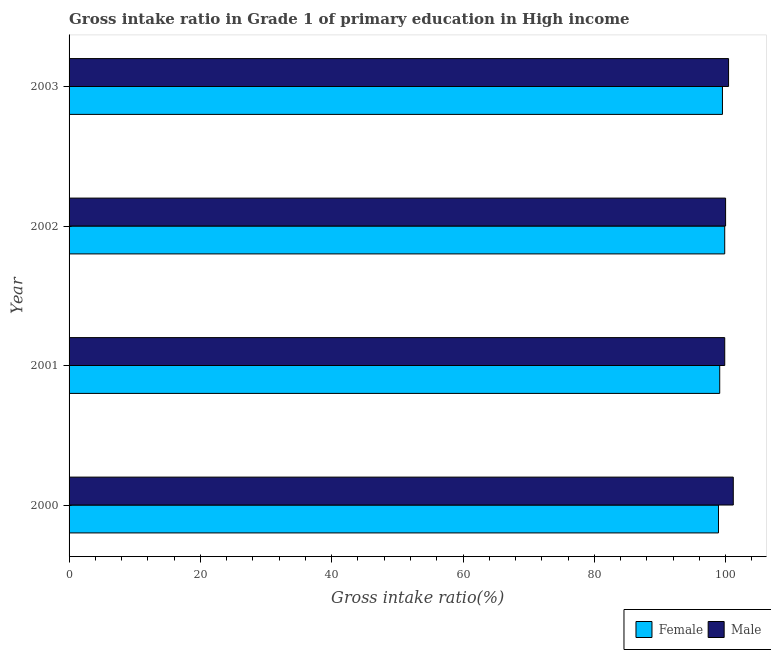How many groups of bars are there?
Keep it short and to the point. 4. Are the number of bars per tick equal to the number of legend labels?
Offer a very short reply. Yes. Are the number of bars on each tick of the Y-axis equal?
Ensure brevity in your answer.  Yes. How many bars are there on the 3rd tick from the top?
Give a very brief answer. 2. What is the gross intake ratio(male) in 2001?
Offer a terse response. 99.86. Across all years, what is the maximum gross intake ratio(female)?
Make the answer very short. 99.86. Across all years, what is the minimum gross intake ratio(female)?
Keep it short and to the point. 98.91. In which year was the gross intake ratio(female) minimum?
Offer a very short reply. 2000. What is the total gross intake ratio(male) in the graph?
Your response must be concise. 401.46. What is the difference between the gross intake ratio(male) in 2001 and that in 2002?
Your answer should be very brief. -0.13. What is the difference between the gross intake ratio(male) in 2000 and the gross intake ratio(female) in 2003?
Your response must be concise. 1.65. What is the average gross intake ratio(female) per year?
Make the answer very short. 99.35. In the year 2001, what is the difference between the gross intake ratio(male) and gross intake ratio(female)?
Your answer should be very brief. 0.76. What is the ratio of the gross intake ratio(male) in 2001 to that in 2003?
Provide a short and direct response. 0.99. Is the difference between the gross intake ratio(male) in 2000 and 2001 greater than the difference between the gross intake ratio(female) in 2000 and 2001?
Keep it short and to the point. Yes. What is the difference between the highest and the second highest gross intake ratio(female)?
Provide a succinct answer. 0.34. In how many years, is the gross intake ratio(female) greater than the average gross intake ratio(female) taken over all years?
Offer a terse response. 2. What does the 2nd bar from the top in 2002 represents?
Provide a short and direct response. Female. What does the 2nd bar from the bottom in 2001 represents?
Your answer should be compact. Male. Are all the bars in the graph horizontal?
Ensure brevity in your answer.  Yes. How many years are there in the graph?
Offer a terse response. 4. Does the graph contain any zero values?
Keep it short and to the point. No. Where does the legend appear in the graph?
Give a very brief answer. Bottom right. How many legend labels are there?
Keep it short and to the point. 2. What is the title of the graph?
Your response must be concise. Gross intake ratio in Grade 1 of primary education in High income. What is the label or title of the X-axis?
Provide a short and direct response. Gross intake ratio(%). What is the Gross intake ratio(%) in Female in 2000?
Make the answer very short. 98.91. What is the Gross intake ratio(%) of Male in 2000?
Provide a succinct answer. 101.16. What is the Gross intake ratio(%) of Female in 2001?
Your response must be concise. 99.1. What is the Gross intake ratio(%) of Male in 2001?
Give a very brief answer. 99.86. What is the Gross intake ratio(%) in Female in 2002?
Provide a succinct answer. 99.86. What is the Gross intake ratio(%) in Male in 2002?
Provide a short and direct response. 99.99. What is the Gross intake ratio(%) in Female in 2003?
Your response must be concise. 99.52. What is the Gross intake ratio(%) in Male in 2003?
Offer a very short reply. 100.44. Across all years, what is the maximum Gross intake ratio(%) of Female?
Ensure brevity in your answer.  99.86. Across all years, what is the maximum Gross intake ratio(%) of Male?
Offer a very short reply. 101.16. Across all years, what is the minimum Gross intake ratio(%) in Female?
Offer a very short reply. 98.91. Across all years, what is the minimum Gross intake ratio(%) in Male?
Give a very brief answer. 99.86. What is the total Gross intake ratio(%) of Female in the graph?
Your response must be concise. 397.38. What is the total Gross intake ratio(%) in Male in the graph?
Give a very brief answer. 401.46. What is the difference between the Gross intake ratio(%) in Female in 2000 and that in 2001?
Provide a succinct answer. -0.19. What is the difference between the Gross intake ratio(%) in Male in 2000 and that in 2001?
Ensure brevity in your answer.  1.3. What is the difference between the Gross intake ratio(%) in Female in 2000 and that in 2002?
Make the answer very short. -0.95. What is the difference between the Gross intake ratio(%) in Male in 2000 and that in 2002?
Your response must be concise. 1.17. What is the difference between the Gross intake ratio(%) in Female in 2000 and that in 2003?
Your answer should be compact. -0.61. What is the difference between the Gross intake ratio(%) of Male in 2000 and that in 2003?
Ensure brevity in your answer.  0.72. What is the difference between the Gross intake ratio(%) in Female in 2001 and that in 2002?
Ensure brevity in your answer.  -0.76. What is the difference between the Gross intake ratio(%) of Male in 2001 and that in 2002?
Offer a terse response. -0.13. What is the difference between the Gross intake ratio(%) of Female in 2001 and that in 2003?
Provide a short and direct response. -0.42. What is the difference between the Gross intake ratio(%) of Male in 2001 and that in 2003?
Make the answer very short. -0.58. What is the difference between the Gross intake ratio(%) of Female in 2002 and that in 2003?
Keep it short and to the point. 0.34. What is the difference between the Gross intake ratio(%) in Male in 2002 and that in 2003?
Give a very brief answer. -0.45. What is the difference between the Gross intake ratio(%) of Female in 2000 and the Gross intake ratio(%) of Male in 2001?
Offer a terse response. -0.95. What is the difference between the Gross intake ratio(%) of Female in 2000 and the Gross intake ratio(%) of Male in 2002?
Provide a short and direct response. -1.08. What is the difference between the Gross intake ratio(%) of Female in 2000 and the Gross intake ratio(%) of Male in 2003?
Ensure brevity in your answer.  -1.54. What is the difference between the Gross intake ratio(%) in Female in 2001 and the Gross intake ratio(%) in Male in 2002?
Offer a terse response. -0.89. What is the difference between the Gross intake ratio(%) of Female in 2001 and the Gross intake ratio(%) of Male in 2003?
Ensure brevity in your answer.  -1.35. What is the difference between the Gross intake ratio(%) in Female in 2002 and the Gross intake ratio(%) in Male in 2003?
Offer a terse response. -0.59. What is the average Gross intake ratio(%) of Female per year?
Keep it short and to the point. 99.35. What is the average Gross intake ratio(%) in Male per year?
Give a very brief answer. 100.37. In the year 2000, what is the difference between the Gross intake ratio(%) in Female and Gross intake ratio(%) in Male?
Offer a terse response. -2.25. In the year 2001, what is the difference between the Gross intake ratio(%) in Female and Gross intake ratio(%) in Male?
Offer a terse response. -0.76. In the year 2002, what is the difference between the Gross intake ratio(%) in Female and Gross intake ratio(%) in Male?
Keep it short and to the point. -0.13. In the year 2003, what is the difference between the Gross intake ratio(%) in Female and Gross intake ratio(%) in Male?
Provide a short and direct response. -0.93. What is the ratio of the Gross intake ratio(%) of Male in 2000 to that in 2002?
Your answer should be very brief. 1.01. What is the ratio of the Gross intake ratio(%) in Female in 2000 to that in 2003?
Make the answer very short. 0.99. What is the ratio of the Gross intake ratio(%) in Male in 2000 to that in 2003?
Offer a very short reply. 1.01. What is the ratio of the Gross intake ratio(%) of Male in 2001 to that in 2002?
Give a very brief answer. 1. What is the difference between the highest and the second highest Gross intake ratio(%) of Female?
Your answer should be compact. 0.34. What is the difference between the highest and the second highest Gross intake ratio(%) of Male?
Offer a terse response. 0.72. What is the difference between the highest and the lowest Gross intake ratio(%) in Female?
Make the answer very short. 0.95. What is the difference between the highest and the lowest Gross intake ratio(%) in Male?
Make the answer very short. 1.3. 